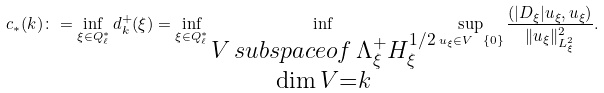Convert formula to latex. <formula><loc_0><loc_0><loc_500><loc_500>c _ { * } ( k ) \colon = \inf _ { \xi \in Q _ { \ell } ^ { * } } d _ { k } ^ { + } ( \xi ) = \inf _ { \xi \in Q _ { \ell } ^ { * } } \inf _ { \substack { V \, s u b s p a c e o f \, \Lambda ^ { + } _ { \xi } H _ { \xi } ^ { 1 / 2 } \\ \dim V = k } } \sup _ { u _ { \xi } \in V \ \{ 0 \} } \frac { \left ( | D _ { \xi } | u _ { \xi } , u _ { \xi } \right ) } { \| u _ { \xi } \| _ { L ^ { 2 } _ { \xi } } ^ { 2 } } .</formula> 